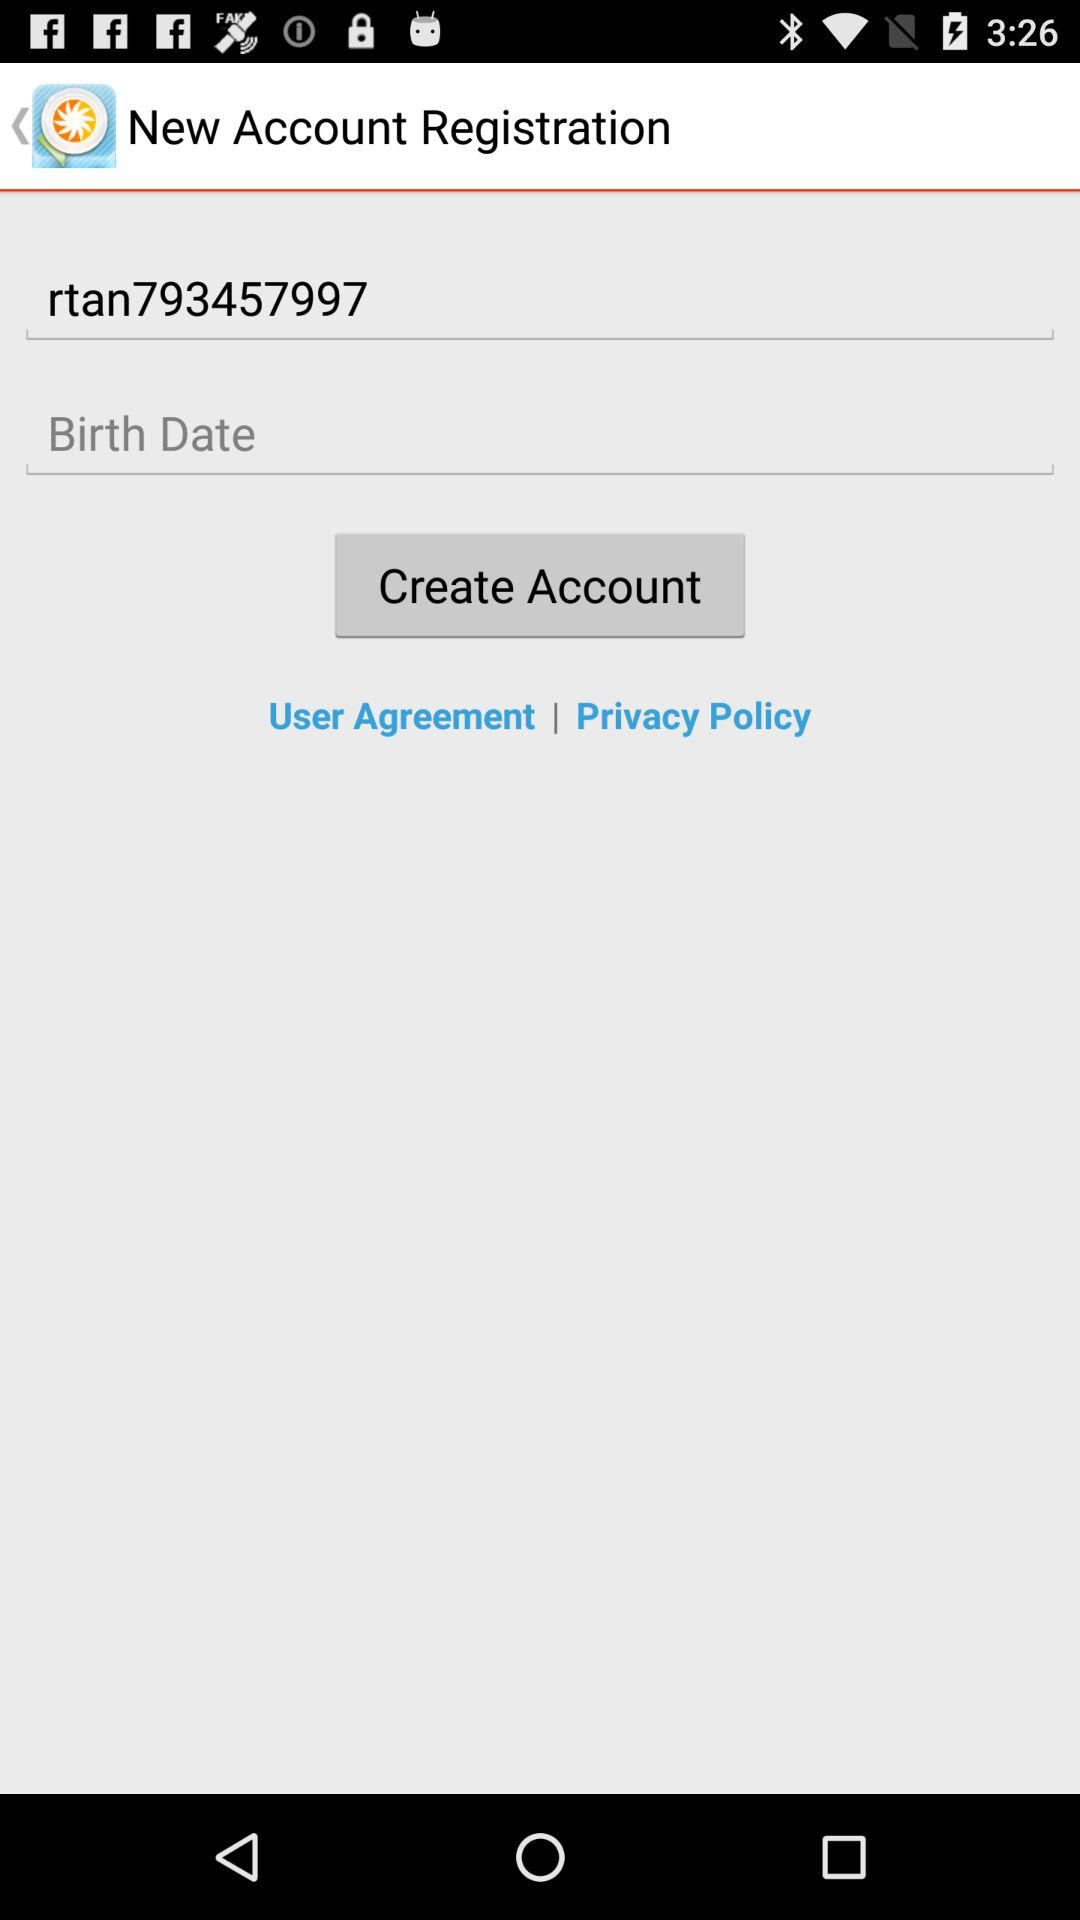What is the username? The username is "rtan793457997". 